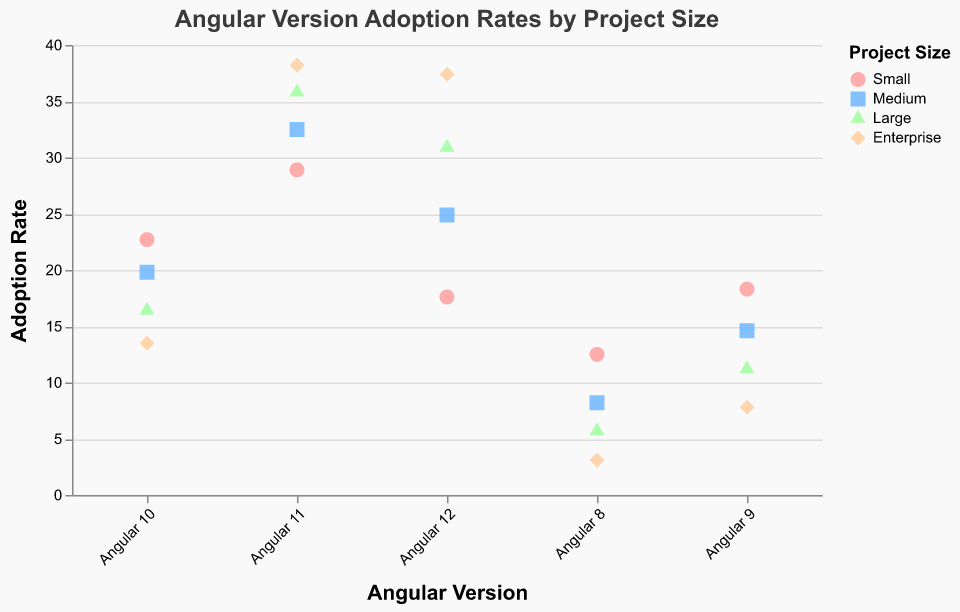What's the title of the figure? The title is usually at the top of the figure. Here, it states "Angular Version Adoption Rates by Project Size."
Answer: Angular Version Adoption Rates by Project Size What is the highest adoption rate for Angular 12 in an Enterprise project? To find this, look at the data points related to Angular 12 for Enterprise projects. The highest adoption rate here is 37.4%.
Answer: 37.4% Which project size has the lowest adoption rate for Angular 8? Compare the adoption rates for Angular 8 across all project sizes. The Enterprise project size has the lowest adoption rate of 3.1%.
Answer: Enterprise How does the adoption rate of Angular 11 change with project size? Examine the adoption rates for Angular 11 across project sizes: Small (28.9), Medium (32.5), Large (35.8), Enterprise (38.2). Adoption increases as the project size gets larger.
Answer: It increases What is the average adoption rate of Angular 10 across all project sizes? Find the adoption rates for Angular 10 across all project sizes: 22.7 (Small), 19.8 (Medium), 16.4 (Large), and 13.5 (Enterprise). Sum them: \(22.7 + 19.8 + 16.4 + 13.5 = 72.4\). Divide by the number of data points (4): \( 72.4 / 4 = 18.1 \).
Answer: 18.1 Which Angular version has the highest adoption rate in Small projects? Check the adoption rates for Angular versions within Small projects, where Angular 11 has the highest adoption rate of 28.9%.
Answer: Angular 11 In which project size does Angular 9 have an adoption rate of 18.3%? Look for the data points specific to Angular 9; 18.3% is for Small project size.
Answer: Small What is the total adoption rate of Angular 12 across all project sizes? Add up the adoption rates for Angular 12 across all sizes: 17.6 (Small), 24.9 (Medium), 30.9 (Large), and 37.4 (Enterprise). Calculation: \(17.6 + 24.9 + 30.9 + 37.4 = 110.8\).
Answer: 110.8 Which project size shows the most significant increase in adoption rate from Angular 8 to Angular 11? Calculate the difference in adoption rates from Angular 8 to Angular 11 for each size:
Small: \(28.9 - 12.5 = 16.4\),
Medium: \(32.5 - 8.2 = 24.3\),
Large: \(35.8 - 5.7 = 30.1\),
Enterprise: \(38.2 - 3.1 = 35.1\).
Enterprise shows the most significant increase of 35.1.
Answer: Enterprise What shape is used for the data points representing Large projects? Each project size has a unique shape. Here, the shape for Large projects is described as a triangle.
Answer: triangle 